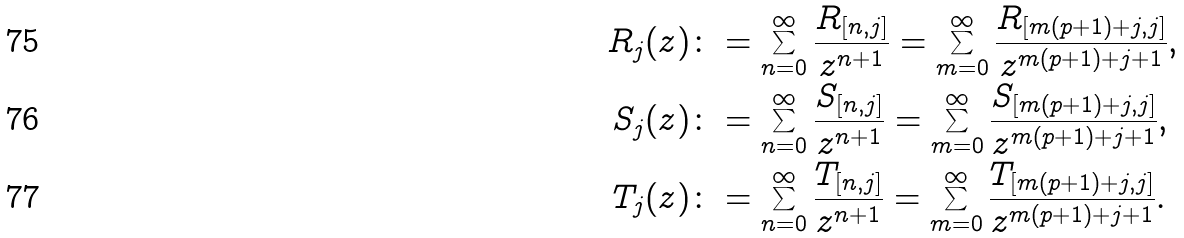Convert formula to latex. <formula><loc_0><loc_0><loc_500><loc_500>R _ { j } ( z ) & \colon = \sum _ { n = 0 } ^ { \infty } \frac { R _ { [ n , j ] } } { z ^ { n + 1 } } = \sum _ { m = 0 } ^ { \infty } \frac { R _ { [ m ( p + 1 ) + j , j ] } } { z ^ { m ( p + 1 ) + j + 1 } } , \\ S _ { j } ( z ) & \colon = \sum _ { n = 0 } ^ { \infty } \frac { S _ { [ n , j ] } } { z ^ { n + 1 } } = \sum _ { m = 0 } ^ { \infty } \frac { S _ { [ m ( p + 1 ) + j , j ] } } { z ^ { m ( p + 1 ) + j + 1 } } , \\ T _ { j } ( z ) & \colon = \sum _ { n = 0 } ^ { \infty } \frac { T _ { [ n , j ] } } { z ^ { n + 1 } } = \sum _ { m = 0 } ^ { \infty } \frac { T _ { [ m ( p + 1 ) + j , j ] } } { z ^ { m ( p + 1 ) + j + 1 } } .</formula> 